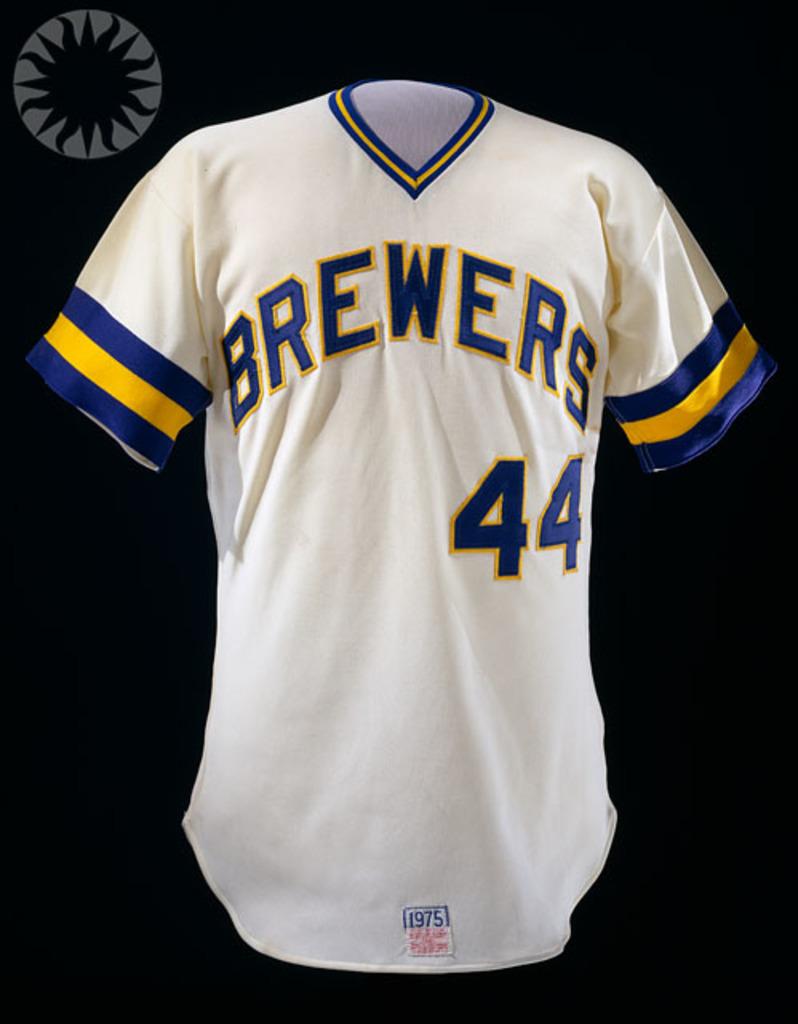What team name is on the jersey?
Your answer should be compact. Brewers. What jersey number is this?
Make the answer very short. 44. 